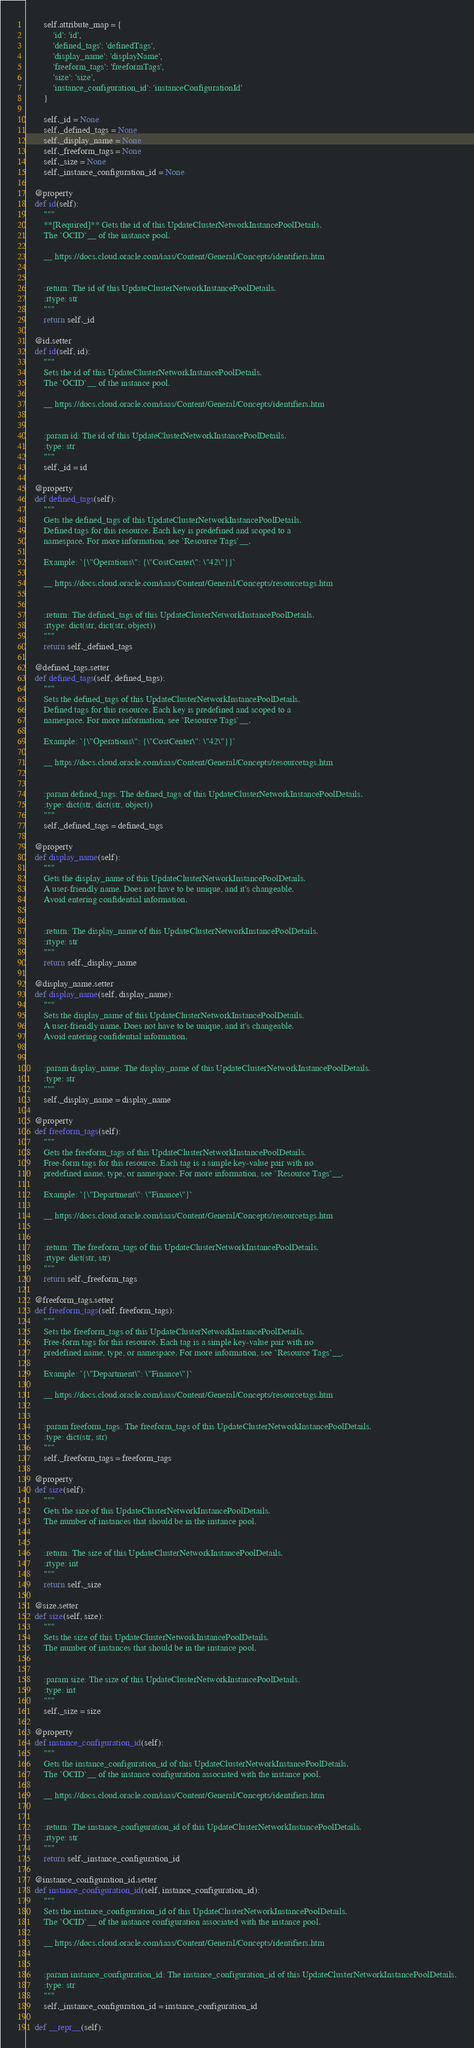<code> <loc_0><loc_0><loc_500><loc_500><_Python_>        self.attribute_map = {
            'id': 'id',
            'defined_tags': 'definedTags',
            'display_name': 'displayName',
            'freeform_tags': 'freeformTags',
            'size': 'size',
            'instance_configuration_id': 'instanceConfigurationId'
        }

        self._id = None
        self._defined_tags = None
        self._display_name = None
        self._freeform_tags = None
        self._size = None
        self._instance_configuration_id = None

    @property
    def id(self):
        """
        **[Required]** Gets the id of this UpdateClusterNetworkInstancePoolDetails.
        The `OCID`__ of the instance pool.

        __ https://docs.cloud.oracle.com/iaas/Content/General/Concepts/identifiers.htm


        :return: The id of this UpdateClusterNetworkInstancePoolDetails.
        :rtype: str
        """
        return self._id

    @id.setter
    def id(self, id):
        """
        Sets the id of this UpdateClusterNetworkInstancePoolDetails.
        The `OCID`__ of the instance pool.

        __ https://docs.cloud.oracle.com/iaas/Content/General/Concepts/identifiers.htm


        :param id: The id of this UpdateClusterNetworkInstancePoolDetails.
        :type: str
        """
        self._id = id

    @property
    def defined_tags(self):
        """
        Gets the defined_tags of this UpdateClusterNetworkInstancePoolDetails.
        Defined tags for this resource. Each key is predefined and scoped to a
        namespace. For more information, see `Resource Tags`__.

        Example: `{\"Operations\": {\"CostCenter\": \"42\"}}`

        __ https://docs.cloud.oracle.com/iaas/Content/General/Concepts/resourcetags.htm


        :return: The defined_tags of this UpdateClusterNetworkInstancePoolDetails.
        :rtype: dict(str, dict(str, object))
        """
        return self._defined_tags

    @defined_tags.setter
    def defined_tags(self, defined_tags):
        """
        Sets the defined_tags of this UpdateClusterNetworkInstancePoolDetails.
        Defined tags for this resource. Each key is predefined and scoped to a
        namespace. For more information, see `Resource Tags`__.

        Example: `{\"Operations\": {\"CostCenter\": \"42\"}}`

        __ https://docs.cloud.oracle.com/iaas/Content/General/Concepts/resourcetags.htm


        :param defined_tags: The defined_tags of this UpdateClusterNetworkInstancePoolDetails.
        :type: dict(str, dict(str, object))
        """
        self._defined_tags = defined_tags

    @property
    def display_name(self):
        """
        Gets the display_name of this UpdateClusterNetworkInstancePoolDetails.
        A user-friendly name. Does not have to be unique, and it's changeable.
        Avoid entering confidential information.


        :return: The display_name of this UpdateClusterNetworkInstancePoolDetails.
        :rtype: str
        """
        return self._display_name

    @display_name.setter
    def display_name(self, display_name):
        """
        Sets the display_name of this UpdateClusterNetworkInstancePoolDetails.
        A user-friendly name. Does not have to be unique, and it's changeable.
        Avoid entering confidential information.


        :param display_name: The display_name of this UpdateClusterNetworkInstancePoolDetails.
        :type: str
        """
        self._display_name = display_name

    @property
    def freeform_tags(self):
        """
        Gets the freeform_tags of this UpdateClusterNetworkInstancePoolDetails.
        Free-form tags for this resource. Each tag is a simple key-value pair with no
        predefined name, type, or namespace. For more information, see `Resource Tags`__.

        Example: `{\"Department\": \"Finance\"}`

        __ https://docs.cloud.oracle.com/iaas/Content/General/Concepts/resourcetags.htm


        :return: The freeform_tags of this UpdateClusterNetworkInstancePoolDetails.
        :rtype: dict(str, str)
        """
        return self._freeform_tags

    @freeform_tags.setter
    def freeform_tags(self, freeform_tags):
        """
        Sets the freeform_tags of this UpdateClusterNetworkInstancePoolDetails.
        Free-form tags for this resource. Each tag is a simple key-value pair with no
        predefined name, type, or namespace. For more information, see `Resource Tags`__.

        Example: `{\"Department\": \"Finance\"}`

        __ https://docs.cloud.oracle.com/iaas/Content/General/Concepts/resourcetags.htm


        :param freeform_tags: The freeform_tags of this UpdateClusterNetworkInstancePoolDetails.
        :type: dict(str, str)
        """
        self._freeform_tags = freeform_tags

    @property
    def size(self):
        """
        Gets the size of this UpdateClusterNetworkInstancePoolDetails.
        The number of instances that should be in the instance pool.


        :return: The size of this UpdateClusterNetworkInstancePoolDetails.
        :rtype: int
        """
        return self._size

    @size.setter
    def size(self, size):
        """
        Sets the size of this UpdateClusterNetworkInstancePoolDetails.
        The number of instances that should be in the instance pool.


        :param size: The size of this UpdateClusterNetworkInstancePoolDetails.
        :type: int
        """
        self._size = size

    @property
    def instance_configuration_id(self):
        """
        Gets the instance_configuration_id of this UpdateClusterNetworkInstancePoolDetails.
        The `OCID`__ of the instance configuration associated with the instance pool.

        __ https://docs.cloud.oracle.com/iaas/Content/General/Concepts/identifiers.htm


        :return: The instance_configuration_id of this UpdateClusterNetworkInstancePoolDetails.
        :rtype: str
        """
        return self._instance_configuration_id

    @instance_configuration_id.setter
    def instance_configuration_id(self, instance_configuration_id):
        """
        Sets the instance_configuration_id of this UpdateClusterNetworkInstancePoolDetails.
        The `OCID`__ of the instance configuration associated with the instance pool.

        __ https://docs.cloud.oracle.com/iaas/Content/General/Concepts/identifiers.htm


        :param instance_configuration_id: The instance_configuration_id of this UpdateClusterNetworkInstancePoolDetails.
        :type: str
        """
        self._instance_configuration_id = instance_configuration_id

    def __repr__(self):</code> 